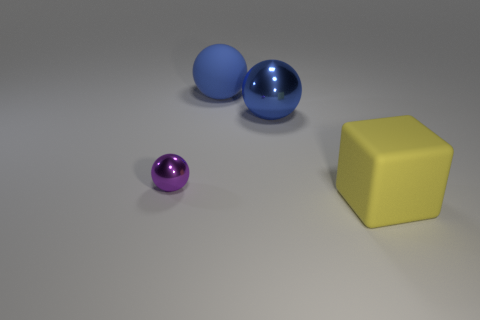Add 2 small yellow objects. How many objects exist? 6 Subtract all balls. How many objects are left? 1 Subtract 0 purple cubes. How many objects are left? 4 Subtract all blue rubber cylinders. Subtract all small spheres. How many objects are left? 3 Add 3 blue metallic objects. How many blue metallic objects are left? 4 Add 4 big yellow things. How many big yellow things exist? 5 